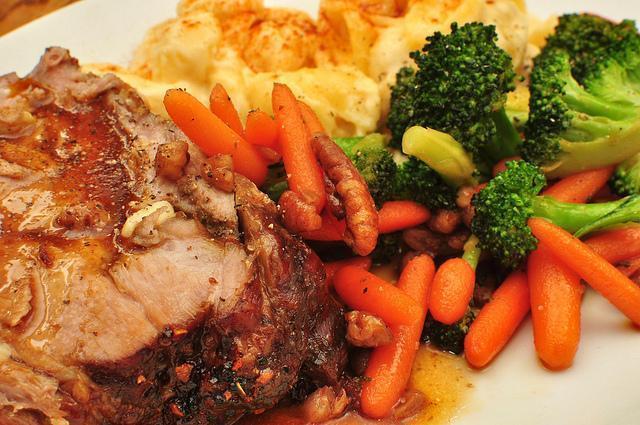How many carrots are visible?
Give a very brief answer. 10. How many broccolis can be seen?
Give a very brief answer. 4. 